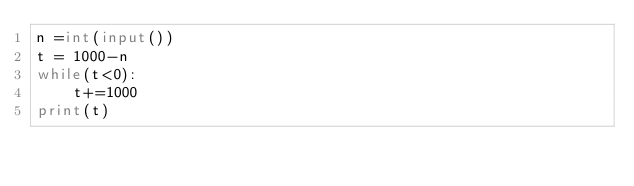<code> <loc_0><loc_0><loc_500><loc_500><_Python_>n =int(input())
t = 1000-n
while(t<0):
    t+=1000
print(t)</code> 